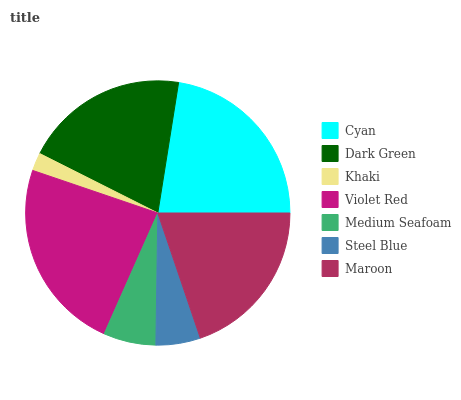Is Khaki the minimum?
Answer yes or no. Yes. Is Violet Red the maximum?
Answer yes or no. Yes. Is Dark Green the minimum?
Answer yes or no. No. Is Dark Green the maximum?
Answer yes or no. No. Is Cyan greater than Dark Green?
Answer yes or no. Yes. Is Dark Green less than Cyan?
Answer yes or no. Yes. Is Dark Green greater than Cyan?
Answer yes or no. No. Is Cyan less than Dark Green?
Answer yes or no. No. Is Maroon the high median?
Answer yes or no. Yes. Is Maroon the low median?
Answer yes or no. Yes. Is Medium Seafoam the high median?
Answer yes or no. No. Is Violet Red the low median?
Answer yes or no. No. 